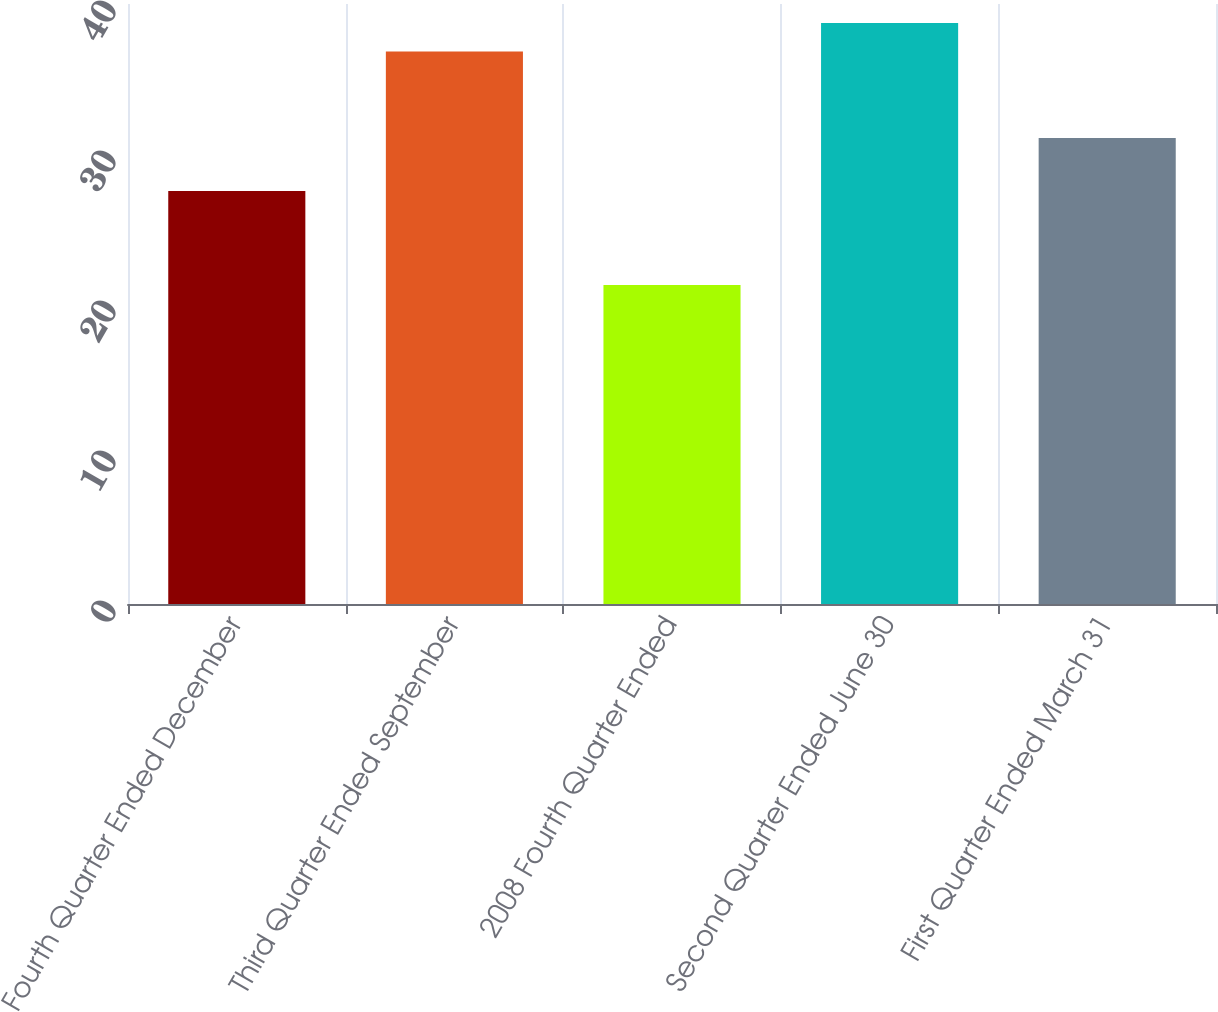<chart> <loc_0><loc_0><loc_500><loc_500><bar_chart><fcel>Fourth Quarter Ended December<fcel>Third Quarter Ended September<fcel>2008 Fourth Quarter Ended<fcel>Second Quarter Ended June 30<fcel>First Quarter Ended March 31<nl><fcel>27.54<fcel>36.84<fcel>21.27<fcel>38.74<fcel>31.07<nl></chart> 